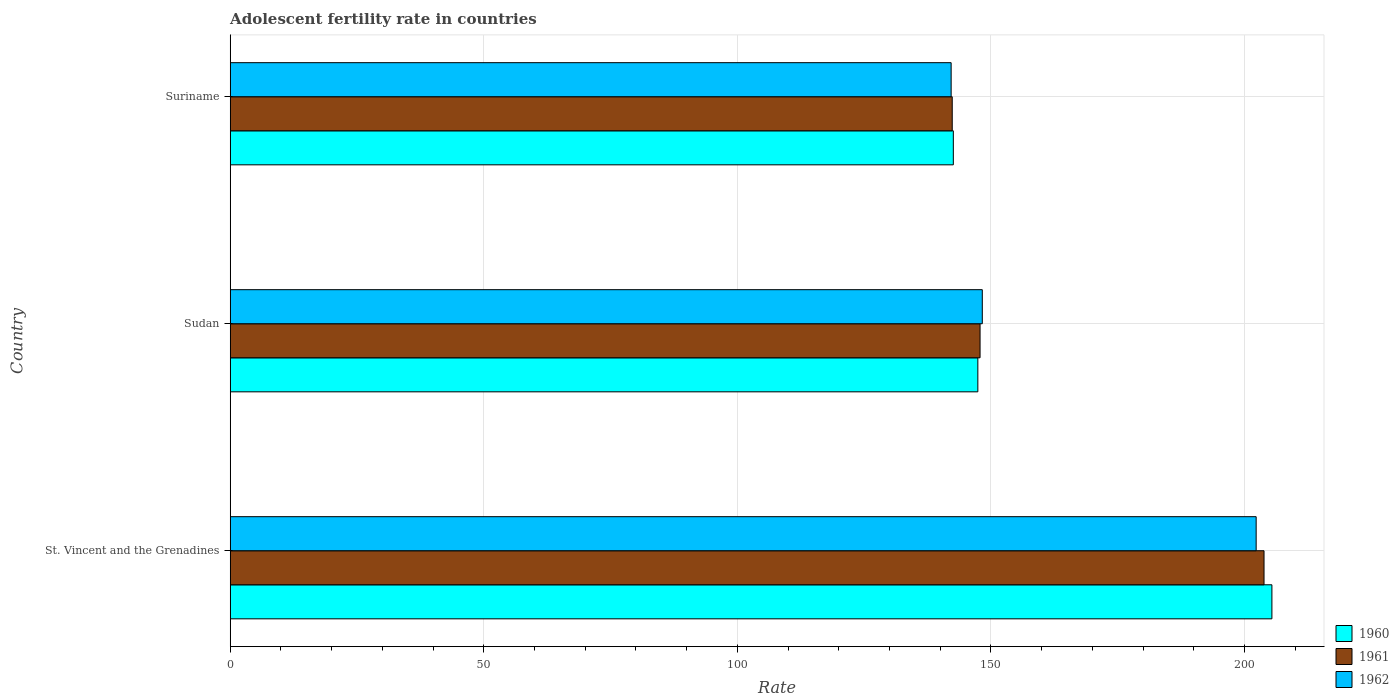Are the number of bars per tick equal to the number of legend labels?
Make the answer very short. Yes. Are the number of bars on each tick of the Y-axis equal?
Your answer should be very brief. Yes. How many bars are there on the 3rd tick from the top?
Your answer should be very brief. 3. How many bars are there on the 2nd tick from the bottom?
Offer a terse response. 3. What is the label of the 1st group of bars from the top?
Give a very brief answer. Suriname. In how many cases, is the number of bars for a given country not equal to the number of legend labels?
Make the answer very short. 0. What is the adolescent fertility rate in 1960 in St. Vincent and the Grenadines?
Give a very brief answer. 205.42. Across all countries, what is the maximum adolescent fertility rate in 1960?
Offer a very short reply. 205.42. Across all countries, what is the minimum adolescent fertility rate in 1960?
Your answer should be compact. 142.6. In which country was the adolescent fertility rate in 1961 maximum?
Your answer should be very brief. St. Vincent and the Grenadines. In which country was the adolescent fertility rate in 1961 minimum?
Offer a very short reply. Suriname. What is the total adolescent fertility rate in 1962 in the graph?
Make the answer very short. 492.8. What is the difference between the adolescent fertility rate in 1962 in St. Vincent and the Grenadines and that in Sudan?
Your answer should be very brief. 54. What is the difference between the adolescent fertility rate in 1961 in St. Vincent and the Grenadines and the adolescent fertility rate in 1962 in Suriname?
Offer a terse response. 61.7. What is the average adolescent fertility rate in 1962 per country?
Provide a succinct answer. 164.27. What is the difference between the adolescent fertility rate in 1962 and adolescent fertility rate in 1960 in Suriname?
Ensure brevity in your answer.  -0.43. What is the ratio of the adolescent fertility rate in 1960 in St. Vincent and the Grenadines to that in Sudan?
Your response must be concise. 1.39. Is the adolescent fertility rate in 1962 in St. Vincent and the Grenadines less than that in Sudan?
Offer a very short reply. No. What is the difference between the highest and the second highest adolescent fertility rate in 1961?
Your answer should be compact. 56. What is the difference between the highest and the lowest adolescent fertility rate in 1961?
Your response must be concise. 61.48. Is the sum of the adolescent fertility rate in 1960 in St. Vincent and the Grenadines and Sudan greater than the maximum adolescent fertility rate in 1962 across all countries?
Your answer should be very brief. Yes. What does the 1st bar from the bottom in St. Vincent and the Grenadines represents?
Ensure brevity in your answer.  1960. How many bars are there?
Ensure brevity in your answer.  9. Are all the bars in the graph horizontal?
Provide a short and direct response. Yes. How many countries are there in the graph?
Provide a short and direct response. 3. What is the difference between two consecutive major ticks on the X-axis?
Provide a short and direct response. 50. Are the values on the major ticks of X-axis written in scientific E-notation?
Your answer should be very brief. No. Where does the legend appear in the graph?
Ensure brevity in your answer.  Bottom right. How are the legend labels stacked?
Provide a short and direct response. Vertical. What is the title of the graph?
Keep it short and to the point. Adolescent fertility rate in countries. What is the label or title of the X-axis?
Provide a succinct answer. Rate. What is the label or title of the Y-axis?
Your response must be concise. Country. What is the Rate of 1960 in St. Vincent and the Grenadines?
Your answer should be compact. 205.42. What is the Rate in 1961 in St. Vincent and the Grenadines?
Your response must be concise. 203.87. What is the Rate of 1962 in St. Vincent and the Grenadines?
Ensure brevity in your answer.  202.32. What is the Rate of 1960 in Sudan?
Provide a short and direct response. 147.43. What is the Rate in 1961 in Sudan?
Give a very brief answer. 147.87. What is the Rate of 1962 in Sudan?
Ensure brevity in your answer.  148.31. What is the Rate in 1960 in Suriname?
Ensure brevity in your answer.  142.6. What is the Rate of 1961 in Suriname?
Offer a very short reply. 142.38. What is the Rate of 1962 in Suriname?
Provide a succinct answer. 142.17. Across all countries, what is the maximum Rate in 1960?
Make the answer very short. 205.42. Across all countries, what is the maximum Rate in 1961?
Offer a very short reply. 203.87. Across all countries, what is the maximum Rate in 1962?
Your response must be concise. 202.32. Across all countries, what is the minimum Rate in 1960?
Offer a very short reply. 142.6. Across all countries, what is the minimum Rate of 1961?
Your answer should be very brief. 142.38. Across all countries, what is the minimum Rate of 1962?
Your answer should be very brief. 142.17. What is the total Rate in 1960 in the graph?
Your answer should be compact. 495.45. What is the total Rate in 1961 in the graph?
Keep it short and to the point. 494.12. What is the total Rate in 1962 in the graph?
Provide a succinct answer. 492.8. What is the difference between the Rate of 1960 in St. Vincent and the Grenadines and that in Sudan?
Offer a very short reply. 57.99. What is the difference between the Rate in 1961 in St. Vincent and the Grenadines and that in Sudan?
Your answer should be compact. 56. What is the difference between the Rate of 1962 in St. Vincent and the Grenadines and that in Sudan?
Give a very brief answer. 54.01. What is the difference between the Rate of 1960 in St. Vincent and the Grenadines and that in Suriname?
Keep it short and to the point. 62.82. What is the difference between the Rate in 1961 in St. Vincent and the Grenadines and that in Suriname?
Offer a very short reply. 61.48. What is the difference between the Rate of 1962 in St. Vincent and the Grenadines and that in Suriname?
Offer a terse response. 60.15. What is the difference between the Rate of 1960 in Sudan and that in Suriname?
Ensure brevity in your answer.  4.83. What is the difference between the Rate in 1961 in Sudan and that in Suriname?
Your answer should be very brief. 5.49. What is the difference between the Rate of 1962 in Sudan and that in Suriname?
Provide a succinct answer. 6.14. What is the difference between the Rate in 1960 in St. Vincent and the Grenadines and the Rate in 1961 in Sudan?
Make the answer very short. 57.55. What is the difference between the Rate of 1960 in St. Vincent and the Grenadines and the Rate of 1962 in Sudan?
Keep it short and to the point. 57.11. What is the difference between the Rate of 1961 in St. Vincent and the Grenadines and the Rate of 1962 in Sudan?
Offer a very short reply. 55.56. What is the difference between the Rate of 1960 in St. Vincent and the Grenadines and the Rate of 1961 in Suriname?
Offer a very short reply. 63.04. What is the difference between the Rate in 1960 in St. Vincent and the Grenadines and the Rate in 1962 in Suriname?
Offer a very short reply. 63.25. What is the difference between the Rate in 1961 in St. Vincent and the Grenadines and the Rate in 1962 in Suriname?
Provide a succinct answer. 61.7. What is the difference between the Rate in 1960 in Sudan and the Rate in 1961 in Suriname?
Your answer should be very brief. 5.05. What is the difference between the Rate in 1960 in Sudan and the Rate in 1962 in Suriname?
Give a very brief answer. 5.26. What is the difference between the Rate of 1961 in Sudan and the Rate of 1962 in Suriname?
Offer a very short reply. 5.7. What is the average Rate of 1960 per country?
Keep it short and to the point. 165.15. What is the average Rate of 1961 per country?
Your answer should be compact. 164.71. What is the average Rate of 1962 per country?
Make the answer very short. 164.26. What is the difference between the Rate in 1960 and Rate in 1961 in St. Vincent and the Grenadines?
Keep it short and to the point. 1.55. What is the difference between the Rate of 1960 and Rate of 1962 in St. Vincent and the Grenadines?
Give a very brief answer. 3.1. What is the difference between the Rate in 1961 and Rate in 1962 in St. Vincent and the Grenadines?
Keep it short and to the point. 1.55. What is the difference between the Rate of 1960 and Rate of 1961 in Sudan?
Offer a terse response. -0.44. What is the difference between the Rate of 1960 and Rate of 1962 in Sudan?
Provide a succinct answer. -0.88. What is the difference between the Rate of 1961 and Rate of 1962 in Sudan?
Your answer should be very brief. -0.44. What is the difference between the Rate in 1960 and Rate in 1961 in Suriname?
Ensure brevity in your answer.  0.22. What is the difference between the Rate in 1960 and Rate in 1962 in Suriname?
Your answer should be very brief. 0.43. What is the difference between the Rate in 1961 and Rate in 1962 in Suriname?
Give a very brief answer. 0.22. What is the ratio of the Rate in 1960 in St. Vincent and the Grenadines to that in Sudan?
Your answer should be very brief. 1.39. What is the ratio of the Rate of 1961 in St. Vincent and the Grenadines to that in Sudan?
Keep it short and to the point. 1.38. What is the ratio of the Rate of 1962 in St. Vincent and the Grenadines to that in Sudan?
Provide a succinct answer. 1.36. What is the ratio of the Rate in 1960 in St. Vincent and the Grenadines to that in Suriname?
Your answer should be compact. 1.44. What is the ratio of the Rate of 1961 in St. Vincent and the Grenadines to that in Suriname?
Keep it short and to the point. 1.43. What is the ratio of the Rate in 1962 in St. Vincent and the Grenadines to that in Suriname?
Your answer should be very brief. 1.42. What is the ratio of the Rate in 1960 in Sudan to that in Suriname?
Make the answer very short. 1.03. What is the ratio of the Rate of 1961 in Sudan to that in Suriname?
Offer a terse response. 1.04. What is the ratio of the Rate in 1962 in Sudan to that in Suriname?
Your answer should be compact. 1.04. What is the difference between the highest and the second highest Rate of 1960?
Offer a terse response. 57.99. What is the difference between the highest and the second highest Rate in 1961?
Give a very brief answer. 56. What is the difference between the highest and the second highest Rate in 1962?
Provide a succinct answer. 54.01. What is the difference between the highest and the lowest Rate in 1960?
Offer a terse response. 62.82. What is the difference between the highest and the lowest Rate in 1961?
Your response must be concise. 61.48. What is the difference between the highest and the lowest Rate of 1962?
Your response must be concise. 60.15. 